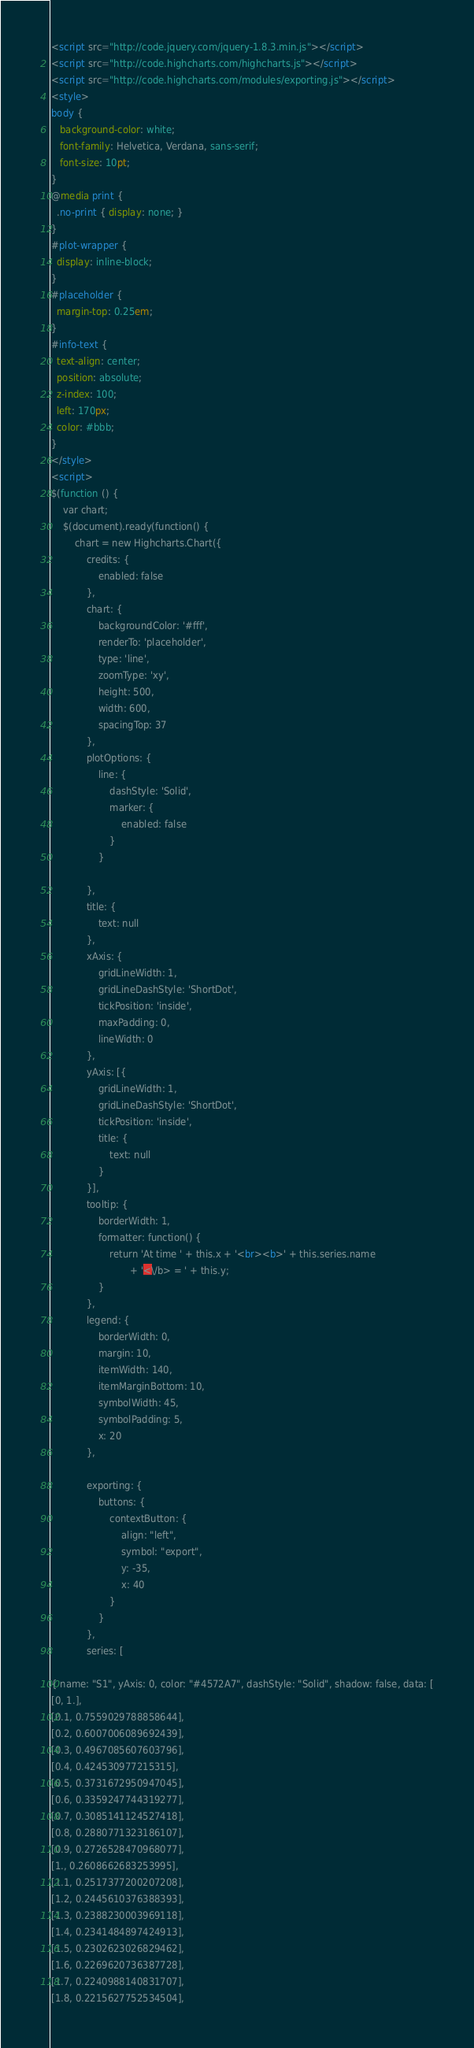<code> <loc_0><loc_0><loc_500><loc_500><_HTML_>
<script src="http://code.jquery.com/jquery-1.8.3.min.js"></script>
<script src="http://code.highcharts.com/highcharts.js"></script>
<script src="http://code.highcharts.com/modules/exporting.js"></script>
<style>
body {
   background-color: white;
   font-family: Helvetica, Verdana, sans-serif;
   font-size: 10pt;
}
@media print {
  .no-print { display: none; }
}
#plot-wrapper {
  display: inline-block;
}
#placeholder {
  margin-top: 0.25em;
}
#info-text {
  text-align: center;
  position: absolute;
  z-index: 100;
  left: 170px;
  color: #bbb;
}
</style>
<script>
$(function () {
    var chart;
    $(document).ready(function() {
        chart = new Highcharts.Chart({
            credits: {
                enabled: false
            },
            chart: {
                backgroundColor: '#fff',
                renderTo: 'placeholder',
                type: 'line',
                zoomType: 'xy',
                height: 500,
                width: 600,
                spacingTop: 37
            },
            plotOptions: {
                line: {
                    dashStyle: 'Solid',
                    marker: {
                        enabled: false
                    }
                }

            },
            title: {
                text: null
            },
            xAxis: {
                gridLineWidth: 1,
                gridLineDashStyle: 'ShortDot',
                tickPosition: 'inside',
                maxPadding: 0,
                lineWidth: 0
            },
            yAxis: [{
                gridLineWidth: 1,
                gridLineDashStyle: 'ShortDot',
                tickPosition: 'inside',
                title: {
                    text: null
                }
            }],
            tooltip: {
                borderWidth: 1,
                formatter: function() {
                    return 'At time ' + this.x + '<br><b>' + this.series.name
                           + '<\/b> = ' + this.y;
                }
            },
            legend: {
                borderWidth: 0,
                margin: 10,
                itemWidth: 140,
                itemMarginBottom: 10,
                symbolWidth: 45,
                symbolPadding: 5,
                x: 20
            },

            exporting: {
                buttons: {
                    contextButton: {
                        align: "left",
                        symbol: "export",
                        y: -35,
                        x: 40
                    }
                }
            },
            series: [

{ name: "S1", yAxis: 0, color: "#4572A7", dashStyle: "Solid", shadow: false, data: [
[0, 1.],
[0.1, 0.7559029788858644],
[0.2, 0.6007006089692439],
[0.3, 0.4967085607603796],
[0.4, 0.424530977215315],
[0.5, 0.3731672950947045],
[0.6, 0.3359247744319277],
[0.7, 0.3085141124527418],
[0.8, 0.2880771323186107],
[0.9, 0.2726528470968077],
[1., 0.2608662683253995],
[1.1, 0.2517377200207208],
[1.2, 0.2445610376388393],
[1.3, 0.2388230003969118],
[1.4, 0.2341484897424913],
[1.5, 0.2302623026829462],
[1.6, 0.2269620736387728],
[1.7, 0.2240988140831707],
[1.8, 0.2215627752534504],</code> 